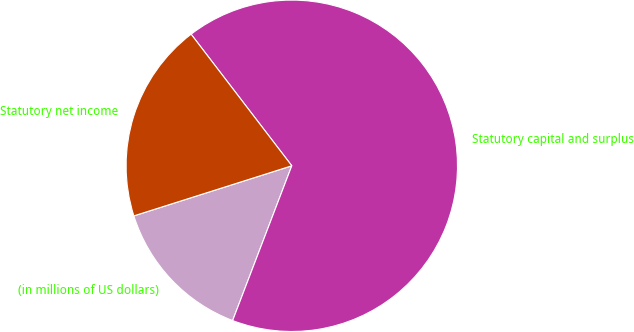Convert chart. <chart><loc_0><loc_0><loc_500><loc_500><pie_chart><fcel>(in millions of US dollars)<fcel>Statutory capital and surplus<fcel>Statutory net income<nl><fcel>14.3%<fcel>66.2%<fcel>19.49%<nl></chart> 